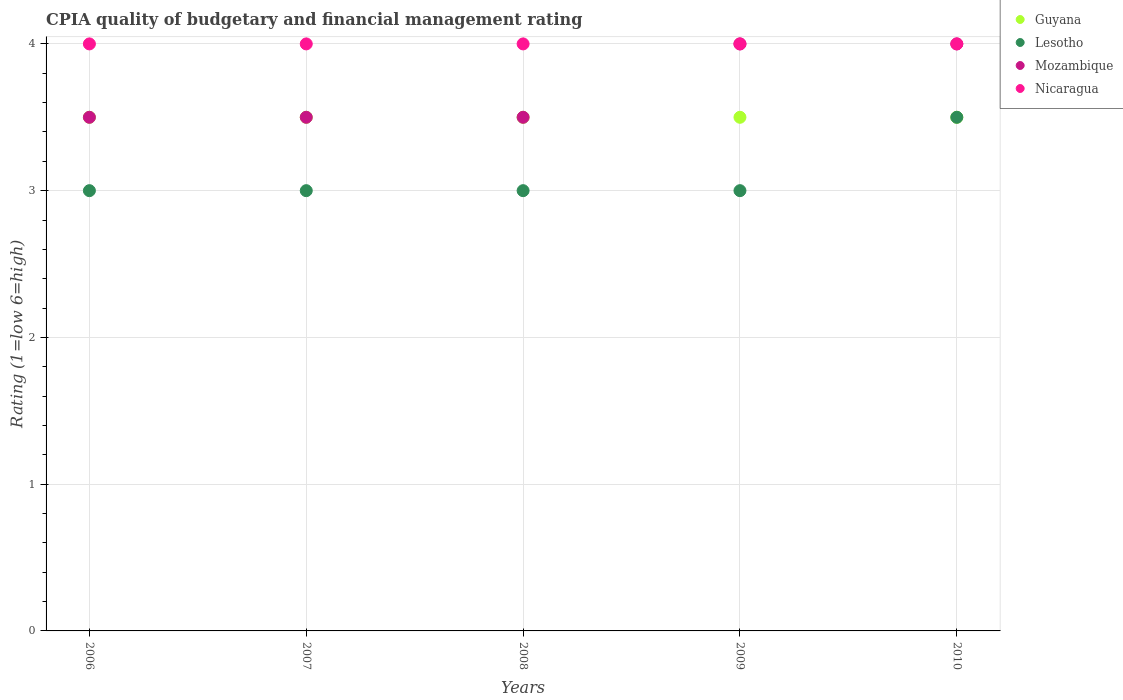Across all years, what is the maximum CPIA rating in Lesotho?
Offer a very short reply. 3.5. In which year was the CPIA rating in Nicaragua maximum?
Your response must be concise. 2006. What is the average CPIA rating in Lesotho per year?
Give a very brief answer. 3.1. In how many years, is the CPIA rating in Guyana greater than 3.2?
Ensure brevity in your answer.  5. What is the ratio of the CPIA rating in Lesotho in 2006 to that in 2009?
Keep it short and to the point. 1. What is the difference between the highest and the second highest CPIA rating in Lesotho?
Give a very brief answer. 0.5. In how many years, is the CPIA rating in Mozambique greater than the average CPIA rating in Mozambique taken over all years?
Your answer should be very brief. 2. Is the sum of the CPIA rating in Nicaragua in 2008 and 2009 greater than the maximum CPIA rating in Guyana across all years?
Your answer should be very brief. Yes. Is it the case that in every year, the sum of the CPIA rating in Mozambique and CPIA rating in Guyana  is greater than the sum of CPIA rating in Nicaragua and CPIA rating in Lesotho?
Keep it short and to the point. No. Does the CPIA rating in Nicaragua monotonically increase over the years?
Your answer should be compact. No. Is the CPIA rating in Nicaragua strictly greater than the CPIA rating in Lesotho over the years?
Offer a terse response. Yes. Are the values on the major ticks of Y-axis written in scientific E-notation?
Provide a short and direct response. No. Does the graph contain any zero values?
Provide a succinct answer. No. Does the graph contain grids?
Your response must be concise. Yes. Where does the legend appear in the graph?
Ensure brevity in your answer.  Top right. How are the legend labels stacked?
Give a very brief answer. Vertical. What is the title of the graph?
Your answer should be compact. CPIA quality of budgetary and financial management rating. Does "Senegal" appear as one of the legend labels in the graph?
Make the answer very short. No. What is the label or title of the X-axis?
Offer a very short reply. Years. What is the Rating (1=low 6=high) of Guyana in 2006?
Offer a very short reply. 3.5. What is the Rating (1=low 6=high) in Nicaragua in 2006?
Provide a short and direct response. 4. What is the Rating (1=low 6=high) of Lesotho in 2007?
Provide a short and direct response. 3. What is the Rating (1=low 6=high) in Mozambique in 2007?
Offer a very short reply. 3.5. What is the Rating (1=low 6=high) in Nicaragua in 2007?
Make the answer very short. 4. What is the Rating (1=low 6=high) of Guyana in 2008?
Offer a terse response. 3.5. What is the Rating (1=low 6=high) of Lesotho in 2008?
Give a very brief answer. 3. What is the Rating (1=low 6=high) in Nicaragua in 2008?
Give a very brief answer. 4. What is the Rating (1=low 6=high) of Lesotho in 2009?
Ensure brevity in your answer.  3. What is the Rating (1=low 6=high) in Nicaragua in 2009?
Offer a terse response. 4. What is the Rating (1=low 6=high) in Lesotho in 2010?
Keep it short and to the point. 3.5. What is the Rating (1=low 6=high) in Nicaragua in 2010?
Keep it short and to the point. 4. Across all years, what is the minimum Rating (1=low 6=high) in Lesotho?
Offer a very short reply. 3. Across all years, what is the minimum Rating (1=low 6=high) in Nicaragua?
Ensure brevity in your answer.  4. What is the total Rating (1=low 6=high) in Guyana in the graph?
Your answer should be compact. 17.5. What is the difference between the Rating (1=low 6=high) in Lesotho in 2006 and that in 2007?
Your response must be concise. 0. What is the difference between the Rating (1=low 6=high) in Lesotho in 2006 and that in 2008?
Offer a terse response. 0. What is the difference between the Rating (1=low 6=high) in Nicaragua in 2006 and that in 2008?
Offer a terse response. 0. What is the difference between the Rating (1=low 6=high) in Guyana in 2006 and that in 2009?
Provide a succinct answer. 0. What is the difference between the Rating (1=low 6=high) of Lesotho in 2006 and that in 2009?
Offer a very short reply. 0. What is the difference between the Rating (1=low 6=high) of Nicaragua in 2006 and that in 2009?
Your response must be concise. 0. What is the difference between the Rating (1=low 6=high) of Mozambique in 2006 and that in 2010?
Make the answer very short. -0.5. What is the difference between the Rating (1=low 6=high) in Nicaragua in 2006 and that in 2010?
Ensure brevity in your answer.  0. What is the difference between the Rating (1=low 6=high) of Guyana in 2007 and that in 2008?
Offer a very short reply. 0. What is the difference between the Rating (1=low 6=high) of Mozambique in 2007 and that in 2008?
Keep it short and to the point. 0. What is the difference between the Rating (1=low 6=high) of Nicaragua in 2007 and that in 2008?
Your response must be concise. 0. What is the difference between the Rating (1=low 6=high) of Guyana in 2007 and that in 2009?
Offer a very short reply. 0. What is the difference between the Rating (1=low 6=high) in Mozambique in 2007 and that in 2009?
Make the answer very short. -0.5. What is the difference between the Rating (1=low 6=high) of Guyana in 2007 and that in 2010?
Provide a short and direct response. 0. What is the difference between the Rating (1=low 6=high) in Guyana in 2008 and that in 2009?
Your answer should be compact. 0. What is the difference between the Rating (1=low 6=high) in Guyana in 2008 and that in 2010?
Ensure brevity in your answer.  0. What is the difference between the Rating (1=low 6=high) in Mozambique in 2008 and that in 2010?
Make the answer very short. -0.5. What is the difference between the Rating (1=low 6=high) in Nicaragua in 2008 and that in 2010?
Provide a succinct answer. 0. What is the difference between the Rating (1=low 6=high) in Lesotho in 2009 and that in 2010?
Provide a short and direct response. -0.5. What is the difference between the Rating (1=low 6=high) of Mozambique in 2009 and that in 2010?
Provide a succinct answer. 0. What is the difference between the Rating (1=low 6=high) of Nicaragua in 2009 and that in 2010?
Give a very brief answer. 0. What is the difference between the Rating (1=low 6=high) in Guyana in 2006 and the Rating (1=low 6=high) in Lesotho in 2007?
Make the answer very short. 0.5. What is the difference between the Rating (1=low 6=high) in Guyana in 2006 and the Rating (1=low 6=high) in Mozambique in 2007?
Make the answer very short. 0. What is the difference between the Rating (1=low 6=high) in Guyana in 2006 and the Rating (1=low 6=high) in Nicaragua in 2007?
Your answer should be compact. -0.5. What is the difference between the Rating (1=low 6=high) in Lesotho in 2006 and the Rating (1=low 6=high) in Mozambique in 2007?
Give a very brief answer. -0.5. What is the difference between the Rating (1=low 6=high) in Mozambique in 2006 and the Rating (1=low 6=high) in Nicaragua in 2007?
Provide a succinct answer. -0.5. What is the difference between the Rating (1=low 6=high) of Guyana in 2006 and the Rating (1=low 6=high) of Lesotho in 2008?
Keep it short and to the point. 0.5. What is the difference between the Rating (1=low 6=high) in Guyana in 2006 and the Rating (1=low 6=high) in Mozambique in 2008?
Keep it short and to the point. 0. What is the difference between the Rating (1=low 6=high) of Guyana in 2006 and the Rating (1=low 6=high) of Nicaragua in 2008?
Provide a short and direct response. -0.5. What is the difference between the Rating (1=low 6=high) in Lesotho in 2006 and the Rating (1=low 6=high) in Nicaragua in 2008?
Provide a succinct answer. -1. What is the difference between the Rating (1=low 6=high) of Lesotho in 2006 and the Rating (1=low 6=high) of Nicaragua in 2009?
Give a very brief answer. -1. What is the difference between the Rating (1=low 6=high) in Mozambique in 2006 and the Rating (1=low 6=high) in Nicaragua in 2009?
Provide a short and direct response. -0.5. What is the difference between the Rating (1=low 6=high) in Guyana in 2006 and the Rating (1=low 6=high) in Lesotho in 2010?
Offer a very short reply. 0. What is the difference between the Rating (1=low 6=high) of Lesotho in 2006 and the Rating (1=low 6=high) of Mozambique in 2010?
Offer a very short reply. -1. What is the difference between the Rating (1=low 6=high) in Lesotho in 2006 and the Rating (1=low 6=high) in Nicaragua in 2010?
Offer a very short reply. -1. What is the difference between the Rating (1=low 6=high) in Mozambique in 2006 and the Rating (1=low 6=high) in Nicaragua in 2010?
Make the answer very short. -0.5. What is the difference between the Rating (1=low 6=high) of Guyana in 2007 and the Rating (1=low 6=high) of Lesotho in 2008?
Provide a succinct answer. 0.5. What is the difference between the Rating (1=low 6=high) in Guyana in 2007 and the Rating (1=low 6=high) in Mozambique in 2008?
Offer a terse response. 0. What is the difference between the Rating (1=low 6=high) in Guyana in 2007 and the Rating (1=low 6=high) in Nicaragua in 2008?
Give a very brief answer. -0.5. What is the difference between the Rating (1=low 6=high) in Mozambique in 2007 and the Rating (1=low 6=high) in Nicaragua in 2008?
Give a very brief answer. -0.5. What is the difference between the Rating (1=low 6=high) of Guyana in 2007 and the Rating (1=low 6=high) of Mozambique in 2009?
Offer a very short reply. -0.5. What is the difference between the Rating (1=low 6=high) of Lesotho in 2007 and the Rating (1=low 6=high) of Nicaragua in 2009?
Offer a terse response. -1. What is the difference between the Rating (1=low 6=high) in Guyana in 2007 and the Rating (1=low 6=high) in Nicaragua in 2010?
Provide a short and direct response. -0.5. What is the difference between the Rating (1=low 6=high) of Lesotho in 2007 and the Rating (1=low 6=high) of Mozambique in 2010?
Your answer should be compact. -1. What is the difference between the Rating (1=low 6=high) of Lesotho in 2007 and the Rating (1=low 6=high) of Nicaragua in 2010?
Keep it short and to the point. -1. What is the difference between the Rating (1=low 6=high) in Guyana in 2008 and the Rating (1=low 6=high) in Lesotho in 2009?
Your answer should be very brief. 0.5. What is the difference between the Rating (1=low 6=high) in Lesotho in 2008 and the Rating (1=low 6=high) in Mozambique in 2009?
Give a very brief answer. -1. What is the difference between the Rating (1=low 6=high) of Lesotho in 2008 and the Rating (1=low 6=high) of Nicaragua in 2009?
Ensure brevity in your answer.  -1. What is the difference between the Rating (1=low 6=high) of Lesotho in 2008 and the Rating (1=low 6=high) of Nicaragua in 2010?
Offer a terse response. -1. What is the difference between the Rating (1=low 6=high) in Guyana in 2009 and the Rating (1=low 6=high) in Mozambique in 2010?
Give a very brief answer. -0.5. What is the difference between the Rating (1=low 6=high) in Lesotho in 2009 and the Rating (1=low 6=high) in Nicaragua in 2010?
Provide a short and direct response. -1. What is the difference between the Rating (1=low 6=high) in Mozambique in 2009 and the Rating (1=low 6=high) in Nicaragua in 2010?
Make the answer very short. 0. What is the average Rating (1=low 6=high) of Lesotho per year?
Make the answer very short. 3.1. What is the average Rating (1=low 6=high) in Mozambique per year?
Your response must be concise. 3.7. In the year 2006, what is the difference between the Rating (1=low 6=high) of Guyana and Rating (1=low 6=high) of Mozambique?
Offer a terse response. 0. In the year 2006, what is the difference between the Rating (1=low 6=high) in Lesotho and Rating (1=low 6=high) in Mozambique?
Make the answer very short. -0.5. In the year 2006, what is the difference between the Rating (1=low 6=high) in Lesotho and Rating (1=low 6=high) in Nicaragua?
Give a very brief answer. -1. In the year 2007, what is the difference between the Rating (1=low 6=high) of Guyana and Rating (1=low 6=high) of Mozambique?
Provide a short and direct response. 0. In the year 2007, what is the difference between the Rating (1=low 6=high) in Lesotho and Rating (1=low 6=high) in Nicaragua?
Offer a terse response. -1. In the year 2008, what is the difference between the Rating (1=low 6=high) in Guyana and Rating (1=low 6=high) in Nicaragua?
Give a very brief answer. -0.5. In the year 2008, what is the difference between the Rating (1=low 6=high) in Lesotho and Rating (1=low 6=high) in Nicaragua?
Make the answer very short. -1. In the year 2008, what is the difference between the Rating (1=low 6=high) in Mozambique and Rating (1=low 6=high) in Nicaragua?
Provide a succinct answer. -0.5. In the year 2009, what is the difference between the Rating (1=low 6=high) of Guyana and Rating (1=low 6=high) of Lesotho?
Provide a short and direct response. 0.5. In the year 2009, what is the difference between the Rating (1=low 6=high) in Guyana and Rating (1=low 6=high) in Mozambique?
Your response must be concise. -0.5. In the year 2009, what is the difference between the Rating (1=low 6=high) in Lesotho and Rating (1=low 6=high) in Mozambique?
Offer a terse response. -1. In the year 2009, what is the difference between the Rating (1=low 6=high) in Lesotho and Rating (1=low 6=high) in Nicaragua?
Your response must be concise. -1. In the year 2009, what is the difference between the Rating (1=low 6=high) in Mozambique and Rating (1=low 6=high) in Nicaragua?
Keep it short and to the point. 0. In the year 2010, what is the difference between the Rating (1=low 6=high) in Guyana and Rating (1=low 6=high) in Lesotho?
Provide a short and direct response. 0. In the year 2010, what is the difference between the Rating (1=low 6=high) of Guyana and Rating (1=low 6=high) of Mozambique?
Your response must be concise. -0.5. What is the ratio of the Rating (1=low 6=high) of Mozambique in 2006 to that in 2007?
Offer a very short reply. 1. What is the ratio of the Rating (1=low 6=high) in Guyana in 2006 to that in 2008?
Your answer should be very brief. 1. What is the ratio of the Rating (1=low 6=high) in Nicaragua in 2006 to that in 2008?
Offer a very short reply. 1. What is the ratio of the Rating (1=low 6=high) in Guyana in 2006 to that in 2009?
Your response must be concise. 1. What is the ratio of the Rating (1=low 6=high) in Lesotho in 2006 to that in 2009?
Make the answer very short. 1. What is the ratio of the Rating (1=low 6=high) of Mozambique in 2006 to that in 2009?
Provide a short and direct response. 0.88. What is the ratio of the Rating (1=low 6=high) of Lesotho in 2006 to that in 2010?
Your answer should be very brief. 0.86. What is the ratio of the Rating (1=low 6=high) of Mozambique in 2006 to that in 2010?
Provide a short and direct response. 0.88. What is the ratio of the Rating (1=low 6=high) in Nicaragua in 2006 to that in 2010?
Keep it short and to the point. 1. What is the ratio of the Rating (1=low 6=high) in Lesotho in 2007 to that in 2008?
Your answer should be compact. 1. What is the ratio of the Rating (1=low 6=high) of Mozambique in 2007 to that in 2009?
Keep it short and to the point. 0.88. What is the ratio of the Rating (1=low 6=high) in Guyana in 2007 to that in 2010?
Provide a succinct answer. 1. What is the ratio of the Rating (1=low 6=high) in Mozambique in 2007 to that in 2010?
Provide a succinct answer. 0.88. What is the ratio of the Rating (1=low 6=high) in Nicaragua in 2007 to that in 2010?
Offer a terse response. 1. What is the ratio of the Rating (1=low 6=high) of Lesotho in 2008 to that in 2009?
Provide a short and direct response. 1. What is the ratio of the Rating (1=low 6=high) of Nicaragua in 2008 to that in 2009?
Provide a succinct answer. 1. What is the ratio of the Rating (1=low 6=high) of Guyana in 2008 to that in 2010?
Your answer should be compact. 1. What is the ratio of the Rating (1=low 6=high) of Nicaragua in 2008 to that in 2010?
Provide a succinct answer. 1. What is the ratio of the Rating (1=low 6=high) in Lesotho in 2009 to that in 2010?
Give a very brief answer. 0.86. What is the ratio of the Rating (1=low 6=high) of Mozambique in 2009 to that in 2010?
Your response must be concise. 1. What is the difference between the highest and the second highest Rating (1=low 6=high) in Lesotho?
Your answer should be compact. 0.5. What is the difference between the highest and the second highest Rating (1=low 6=high) of Mozambique?
Offer a terse response. 0. What is the difference between the highest and the second highest Rating (1=low 6=high) in Nicaragua?
Offer a terse response. 0. What is the difference between the highest and the lowest Rating (1=low 6=high) in Guyana?
Provide a succinct answer. 0. What is the difference between the highest and the lowest Rating (1=low 6=high) in Mozambique?
Your response must be concise. 0.5. 